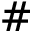Convert formula to latex. <formula><loc_0><loc_0><loc_500><loc_500>\#</formula> 